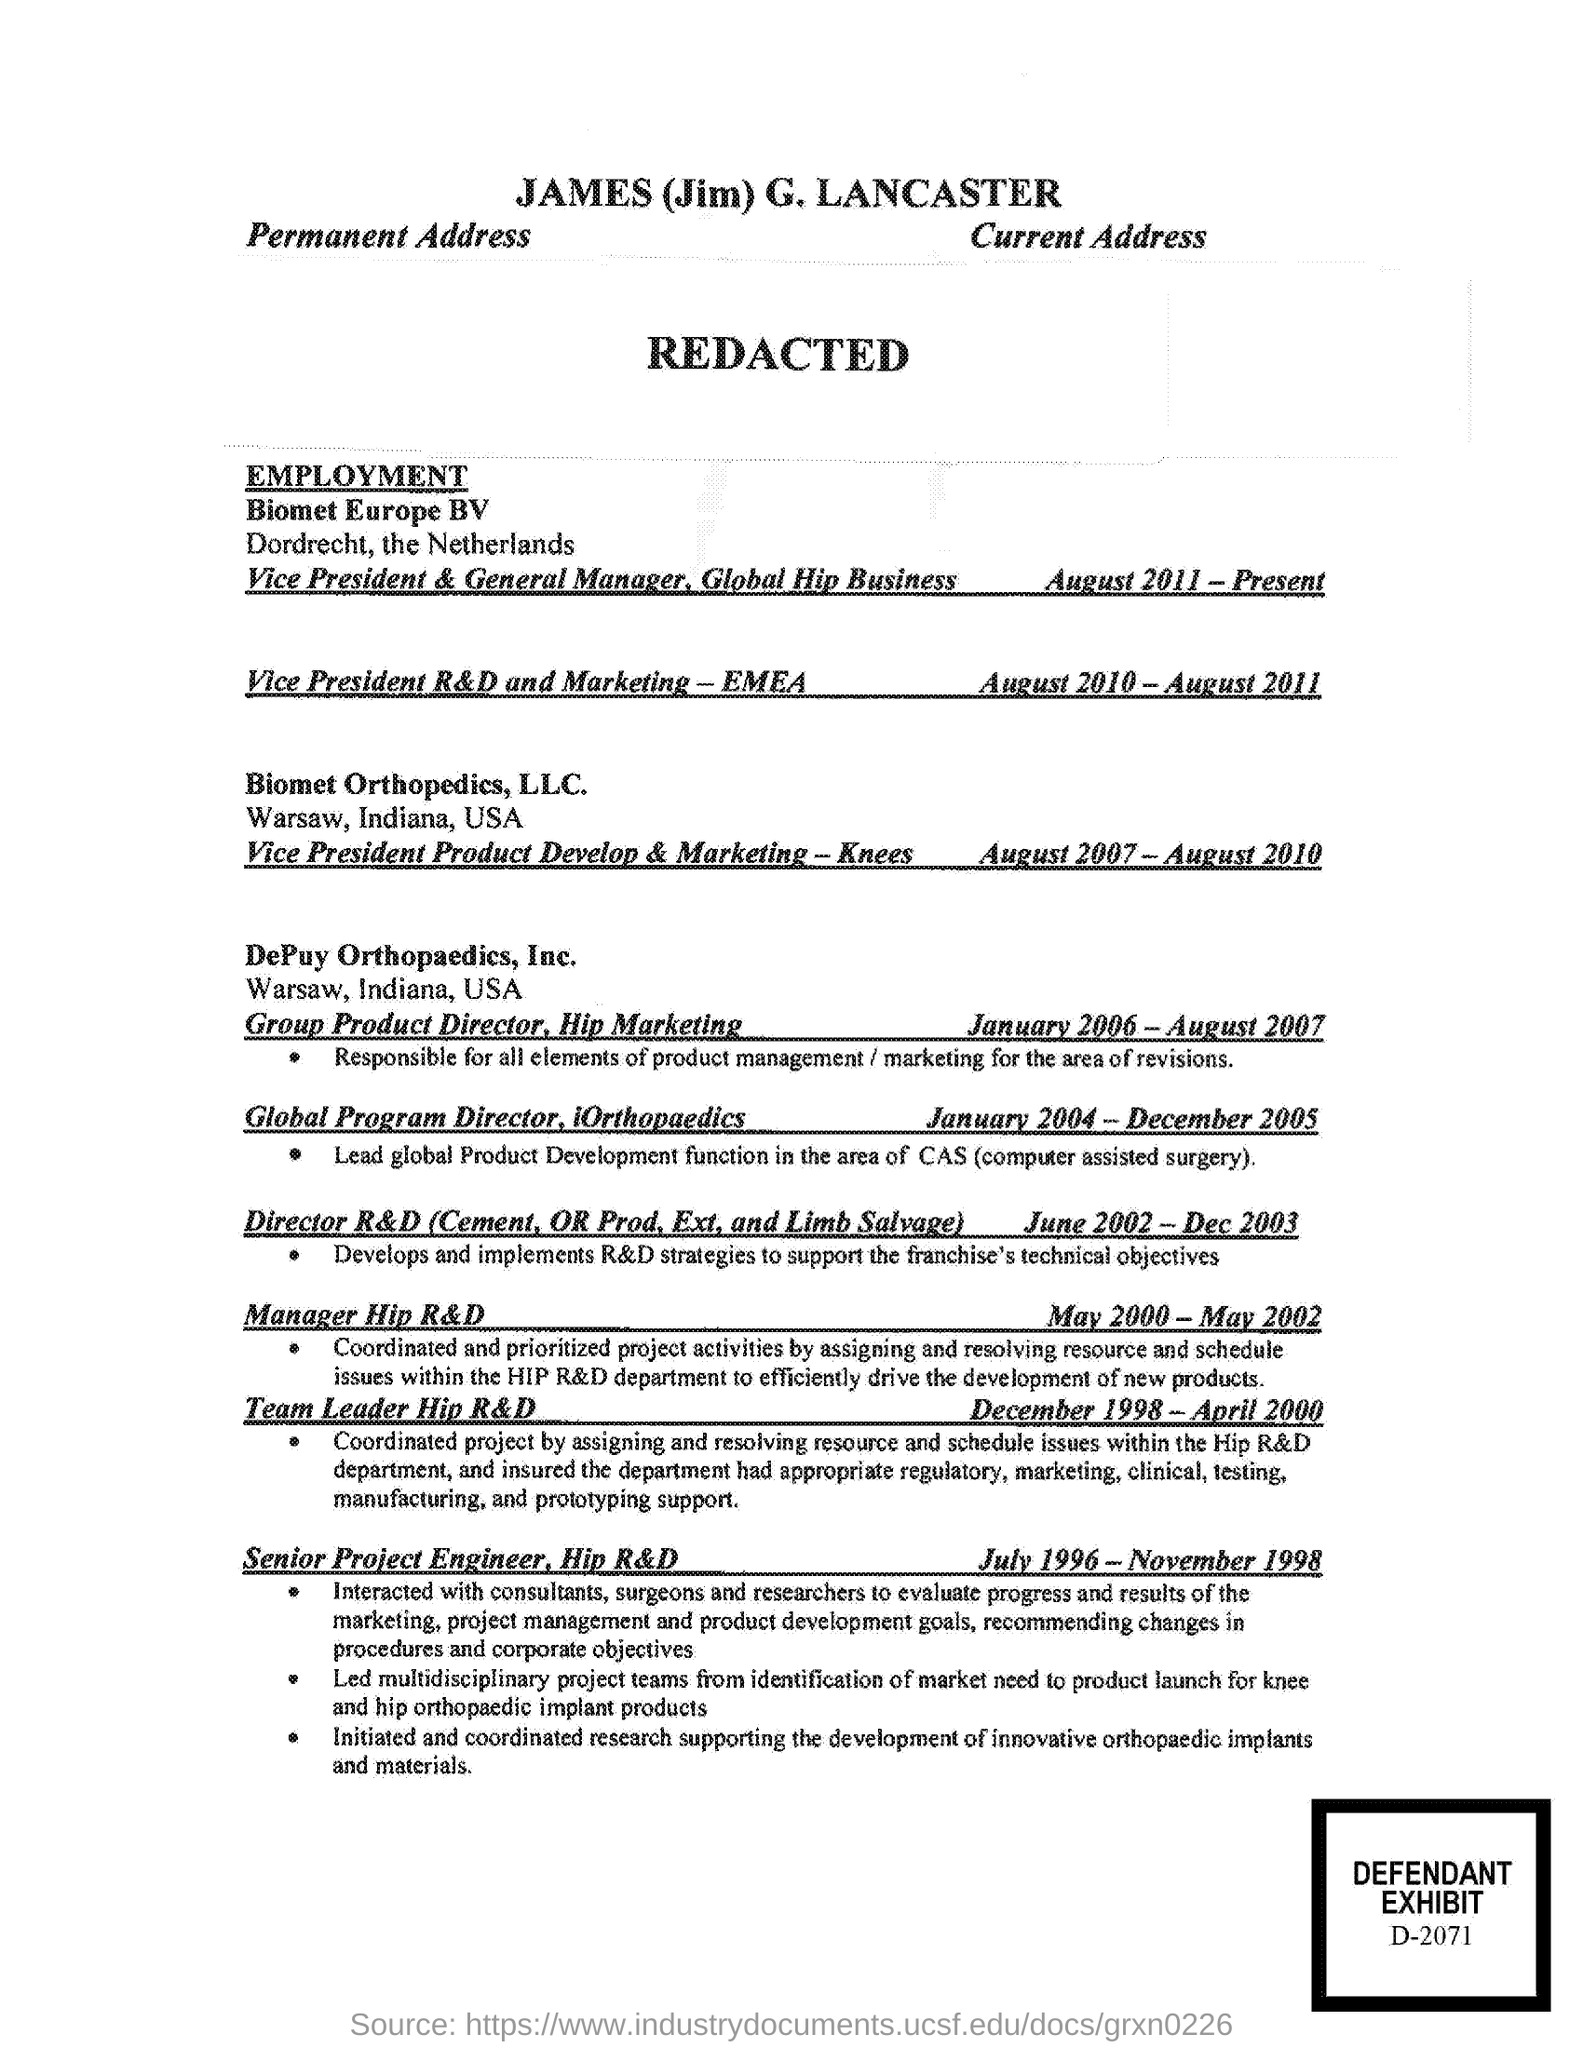What is the defendant exhibit number?
Give a very brief answer. D-2071. 